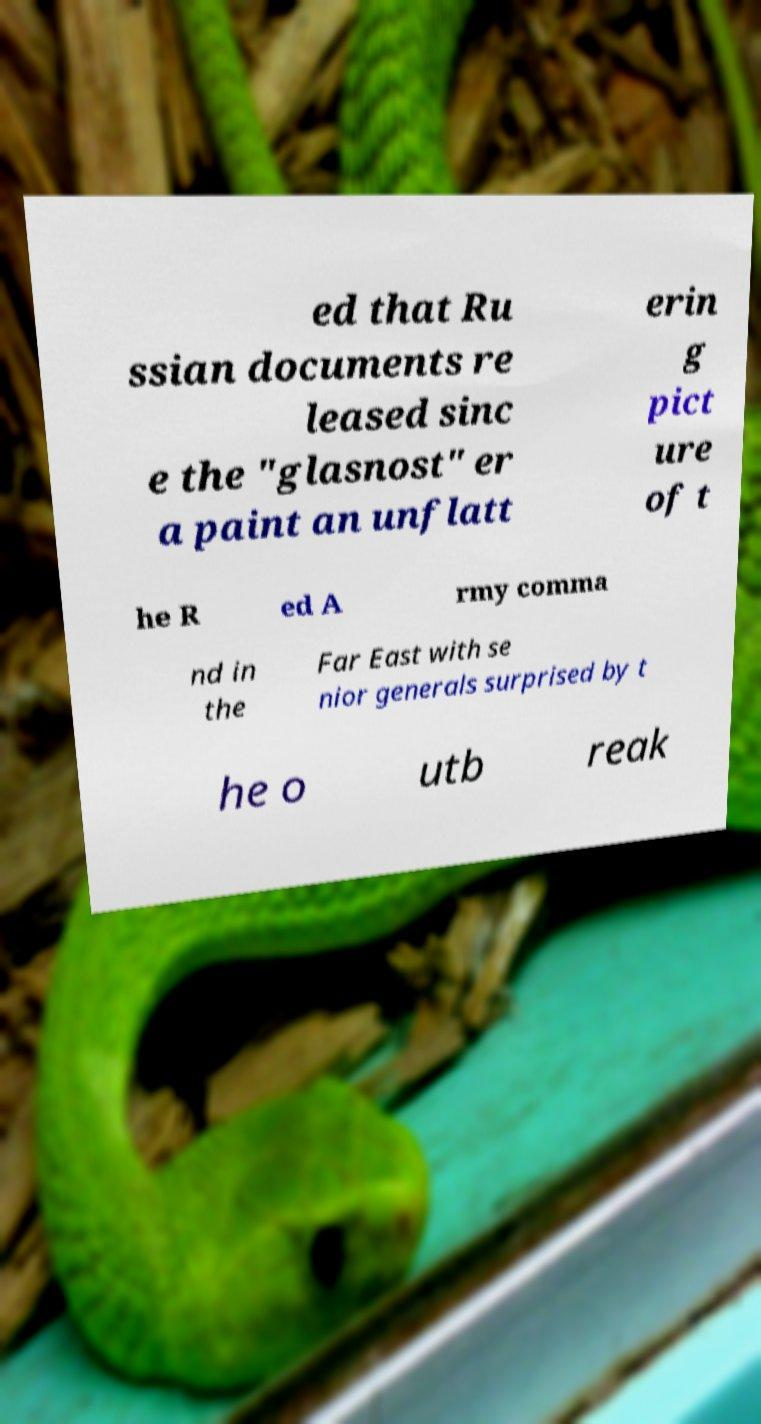What messages or text are displayed in this image? I need them in a readable, typed format. ed that Ru ssian documents re leased sinc e the "glasnost" er a paint an unflatt erin g pict ure of t he R ed A rmy comma nd in the Far East with se nior generals surprised by t he o utb reak 